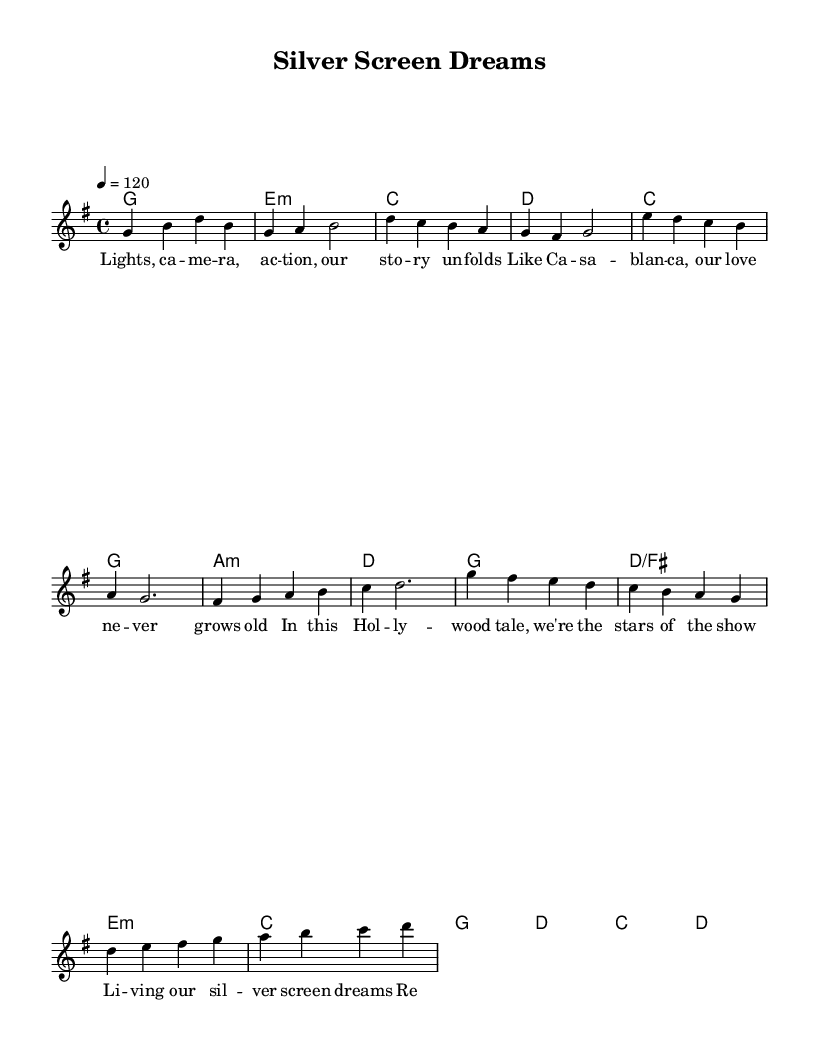What is the key signature of this music? The key signature of the piece is G major, which has one sharp (F#), as indicated at the beginning of the score.
Answer: G major What is the time signature of this music? The time signature shown in the score is 4/4, which means there are four beats per measure and a quarter note gets one beat.
Answer: 4/4 What is the tempo marking for this piece? The tempo is indicated as 120 beats per minute, which is shown in the tempo marking at the beginning of the score.
Answer: 120 How many sections are present in this piece? The music consists of three distinct sections: Verse, Pre-Chorus, and Chorus, which are labeled clearly in the score.
Answer: Three Which movie is referenced in the lyrics of this music? The lyrics reference "Casablanca," which is mentioned in the first verse as part of the cinematic story telling.
Answer: Casablanca What emotional theme is conveyed in the chorus lyrics? The chorus lyrics express a sense of nostalgia and excitement about living out dreams, which reflects a positive and aspirational emotional theme typical in pop music.
Answer: Nostalgia In the Pre-Chorus, what role do the characters have in the context of the lyrics? The characters in the Pre-Chorus are described as "the stars of the show," suggesting they play a central role in the narrative, similar to lead characters in films.
Answer: Stars of the show 